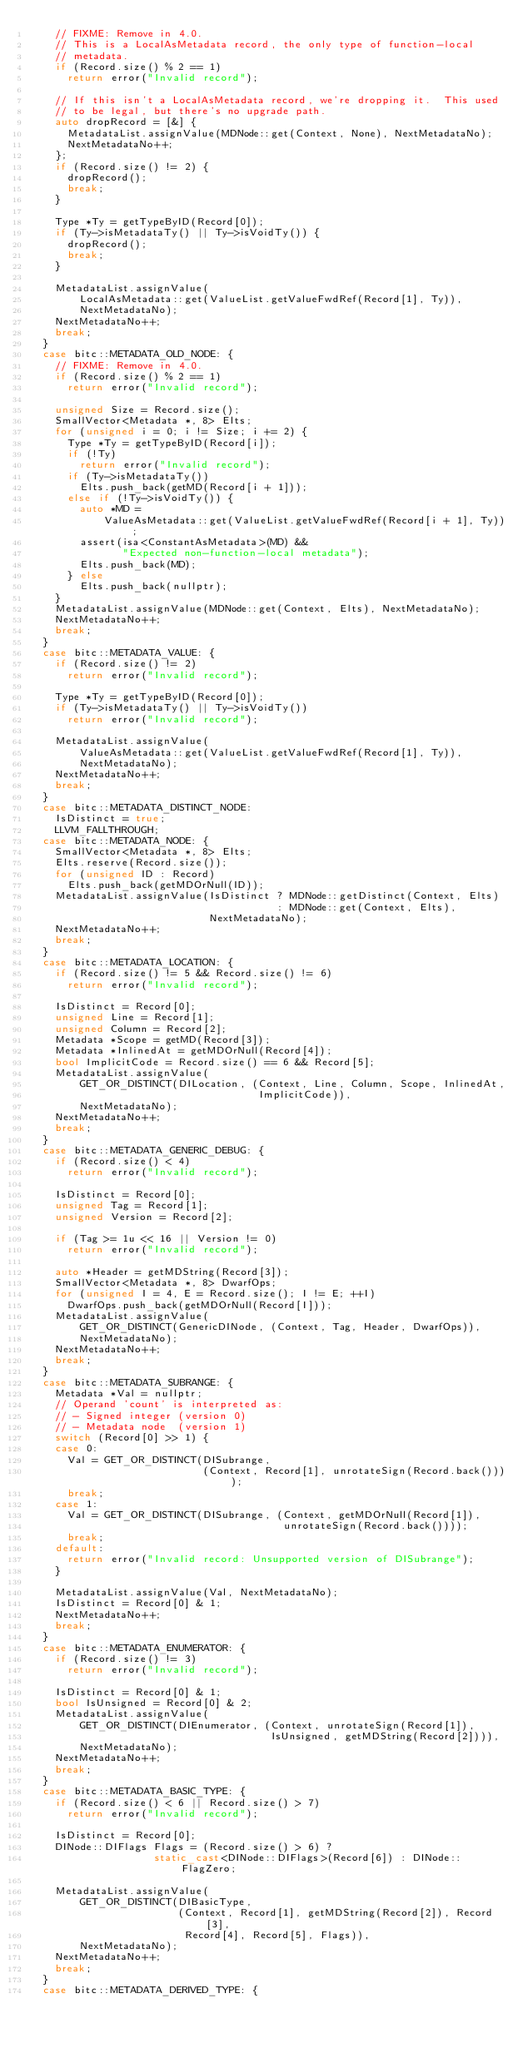Convert code to text. <code><loc_0><loc_0><loc_500><loc_500><_C++_>    // FIXME: Remove in 4.0.
    // This is a LocalAsMetadata record, the only type of function-local
    // metadata.
    if (Record.size() % 2 == 1)
      return error("Invalid record");

    // If this isn't a LocalAsMetadata record, we're dropping it.  This used
    // to be legal, but there's no upgrade path.
    auto dropRecord = [&] {
      MetadataList.assignValue(MDNode::get(Context, None), NextMetadataNo);
      NextMetadataNo++;
    };
    if (Record.size() != 2) {
      dropRecord();
      break;
    }

    Type *Ty = getTypeByID(Record[0]);
    if (Ty->isMetadataTy() || Ty->isVoidTy()) {
      dropRecord();
      break;
    }

    MetadataList.assignValue(
        LocalAsMetadata::get(ValueList.getValueFwdRef(Record[1], Ty)),
        NextMetadataNo);
    NextMetadataNo++;
    break;
  }
  case bitc::METADATA_OLD_NODE: {
    // FIXME: Remove in 4.0.
    if (Record.size() % 2 == 1)
      return error("Invalid record");

    unsigned Size = Record.size();
    SmallVector<Metadata *, 8> Elts;
    for (unsigned i = 0; i != Size; i += 2) {
      Type *Ty = getTypeByID(Record[i]);
      if (!Ty)
        return error("Invalid record");
      if (Ty->isMetadataTy())
        Elts.push_back(getMD(Record[i + 1]));
      else if (!Ty->isVoidTy()) {
        auto *MD =
            ValueAsMetadata::get(ValueList.getValueFwdRef(Record[i + 1], Ty));
        assert(isa<ConstantAsMetadata>(MD) &&
               "Expected non-function-local metadata");
        Elts.push_back(MD);
      } else
        Elts.push_back(nullptr);
    }
    MetadataList.assignValue(MDNode::get(Context, Elts), NextMetadataNo);
    NextMetadataNo++;
    break;
  }
  case bitc::METADATA_VALUE: {
    if (Record.size() != 2)
      return error("Invalid record");

    Type *Ty = getTypeByID(Record[0]);
    if (Ty->isMetadataTy() || Ty->isVoidTy())
      return error("Invalid record");

    MetadataList.assignValue(
        ValueAsMetadata::get(ValueList.getValueFwdRef(Record[1], Ty)),
        NextMetadataNo);
    NextMetadataNo++;
    break;
  }
  case bitc::METADATA_DISTINCT_NODE:
    IsDistinct = true;
    LLVM_FALLTHROUGH;
  case bitc::METADATA_NODE: {
    SmallVector<Metadata *, 8> Elts;
    Elts.reserve(Record.size());
    for (unsigned ID : Record)
      Elts.push_back(getMDOrNull(ID));
    MetadataList.assignValue(IsDistinct ? MDNode::getDistinct(Context, Elts)
                                        : MDNode::get(Context, Elts),
                             NextMetadataNo);
    NextMetadataNo++;
    break;
  }
  case bitc::METADATA_LOCATION: {
    if (Record.size() != 5 && Record.size() != 6)
      return error("Invalid record");

    IsDistinct = Record[0];
    unsigned Line = Record[1];
    unsigned Column = Record[2];
    Metadata *Scope = getMD(Record[3]);
    Metadata *InlinedAt = getMDOrNull(Record[4]);
    bool ImplicitCode = Record.size() == 6 && Record[5];
    MetadataList.assignValue(
        GET_OR_DISTINCT(DILocation, (Context, Line, Column, Scope, InlinedAt,
                                     ImplicitCode)),
        NextMetadataNo);
    NextMetadataNo++;
    break;
  }
  case bitc::METADATA_GENERIC_DEBUG: {
    if (Record.size() < 4)
      return error("Invalid record");

    IsDistinct = Record[0];
    unsigned Tag = Record[1];
    unsigned Version = Record[2];

    if (Tag >= 1u << 16 || Version != 0)
      return error("Invalid record");

    auto *Header = getMDString(Record[3]);
    SmallVector<Metadata *, 8> DwarfOps;
    for (unsigned I = 4, E = Record.size(); I != E; ++I)
      DwarfOps.push_back(getMDOrNull(Record[I]));
    MetadataList.assignValue(
        GET_OR_DISTINCT(GenericDINode, (Context, Tag, Header, DwarfOps)),
        NextMetadataNo);
    NextMetadataNo++;
    break;
  }
  case bitc::METADATA_SUBRANGE: {
    Metadata *Val = nullptr;
    // Operand 'count' is interpreted as:
    // - Signed integer (version 0)
    // - Metadata node  (version 1)
    switch (Record[0] >> 1) {
    case 0:
      Val = GET_OR_DISTINCT(DISubrange,
                            (Context, Record[1], unrotateSign(Record.back())));
      break;
    case 1:
      Val = GET_OR_DISTINCT(DISubrange, (Context, getMDOrNull(Record[1]),
                                         unrotateSign(Record.back())));
      break;
    default:
      return error("Invalid record: Unsupported version of DISubrange");
    }

    MetadataList.assignValue(Val, NextMetadataNo);
    IsDistinct = Record[0] & 1;
    NextMetadataNo++;
    break;
  }
  case bitc::METADATA_ENUMERATOR: {
    if (Record.size() != 3)
      return error("Invalid record");

    IsDistinct = Record[0] & 1;
    bool IsUnsigned = Record[0] & 2;
    MetadataList.assignValue(
        GET_OR_DISTINCT(DIEnumerator, (Context, unrotateSign(Record[1]),
                                       IsUnsigned, getMDString(Record[2]))),
        NextMetadataNo);
    NextMetadataNo++;
    break;
  }
  case bitc::METADATA_BASIC_TYPE: {
    if (Record.size() < 6 || Record.size() > 7)
      return error("Invalid record");

    IsDistinct = Record[0];
    DINode::DIFlags Flags = (Record.size() > 6) ?
                    static_cast<DINode::DIFlags>(Record[6]) : DINode::FlagZero;

    MetadataList.assignValue(
        GET_OR_DISTINCT(DIBasicType,
                        (Context, Record[1], getMDString(Record[2]), Record[3],
                         Record[4], Record[5], Flags)),
        NextMetadataNo);
    NextMetadataNo++;
    break;
  }
  case bitc::METADATA_DERIVED_TYPE: {</code> 